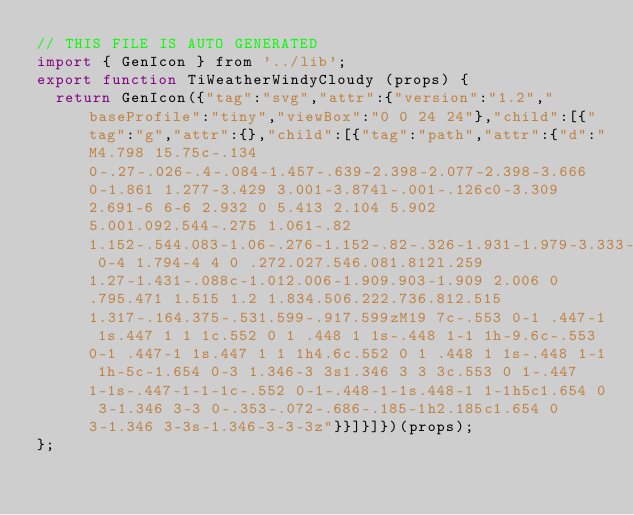<code> <loc_0><loc_0><loc_500><loc_500><_JavaScript_>// THIS FILE IS AUTO GENERATED
import { GenIcon } from '../lib';
export function TiWeatherWindyCloudy (props) {
  return GenIcon({"tag":"svg","attr":{"version":"1.2","baseProfile":"tiny","viewBox":"0 0 24 24"},"child":[{"tag":"g","attr":{},"child":[{"tag":"path","attr":{"d":"M4.798 15.75c-.134 0-.27-.026-.4-.084-1.457-.639-2.398-2.077-2.398-3.666 0-1.861 1.277-3.429 3.001-3.874l-.001-.126c0-3.309 2.691-6 6-6 2.932 0 5.413 2.104 5.902 5.001.092.544-.275 1.061-.82 1.152-.544.083-1.06-.276-1.152-.82-.326-1.931-1.979-3.333-3.93-3.333-2.206 0-4 1.794-4 4 0 .272.027.546.081.812l.259 1.27-1.431-.088c-1.012.006-1.909.903-1.909 2.006 0 .795.471 1.515 1.2 1.834.506.222.736.812.515 1.317-.164.375-.531.599-.917.599zM19 7c-.553 0-1 .447-1 1s.447 1 1 1c.552 0 1 .448 1 1s-.448 1-1 1h-9.6c-.553 0-1 .447-1 1s.447 1 1 1h4.6c.552 0 1 .448 1 1s-.448 1-1 1h-5c-1.654 0-3 1.346-3 3s1.346 3 3 3c.553 0 1-.447 1-1s-.447-1-1-1c-.552 0-1-.448-1-1s.448-1 1-1h5c1.654 0 3-1.346 3-3 0-.353-.072-.686-.185-1h2.185c1.654 0 3-1.346 3-3s-1.346-3-3-3z"}}]}]})(props);
};
</code> 